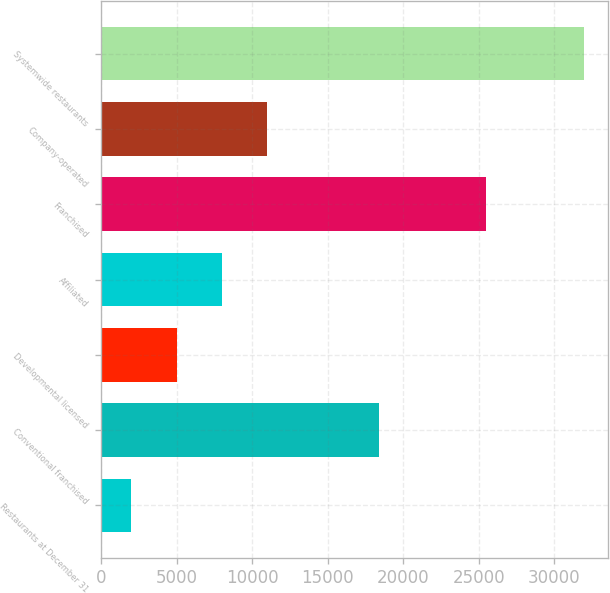<chart> <loc_0><loc_0><loc_500><loc_500><bar_chart><fcel>Restaurants at December 31<fcel>Conventional franchised<fcel>Developmental licensed<fcel>Affiliated<fcel>Franchised<fcel>Company-operated<fcel>Systemwide restaurants<nl><fcel>2008<fcel>18402<fcel>5003.9<fcel>7999.8<fcel>25465<fcel>10995.7<fcel>31967<nl></chart> 